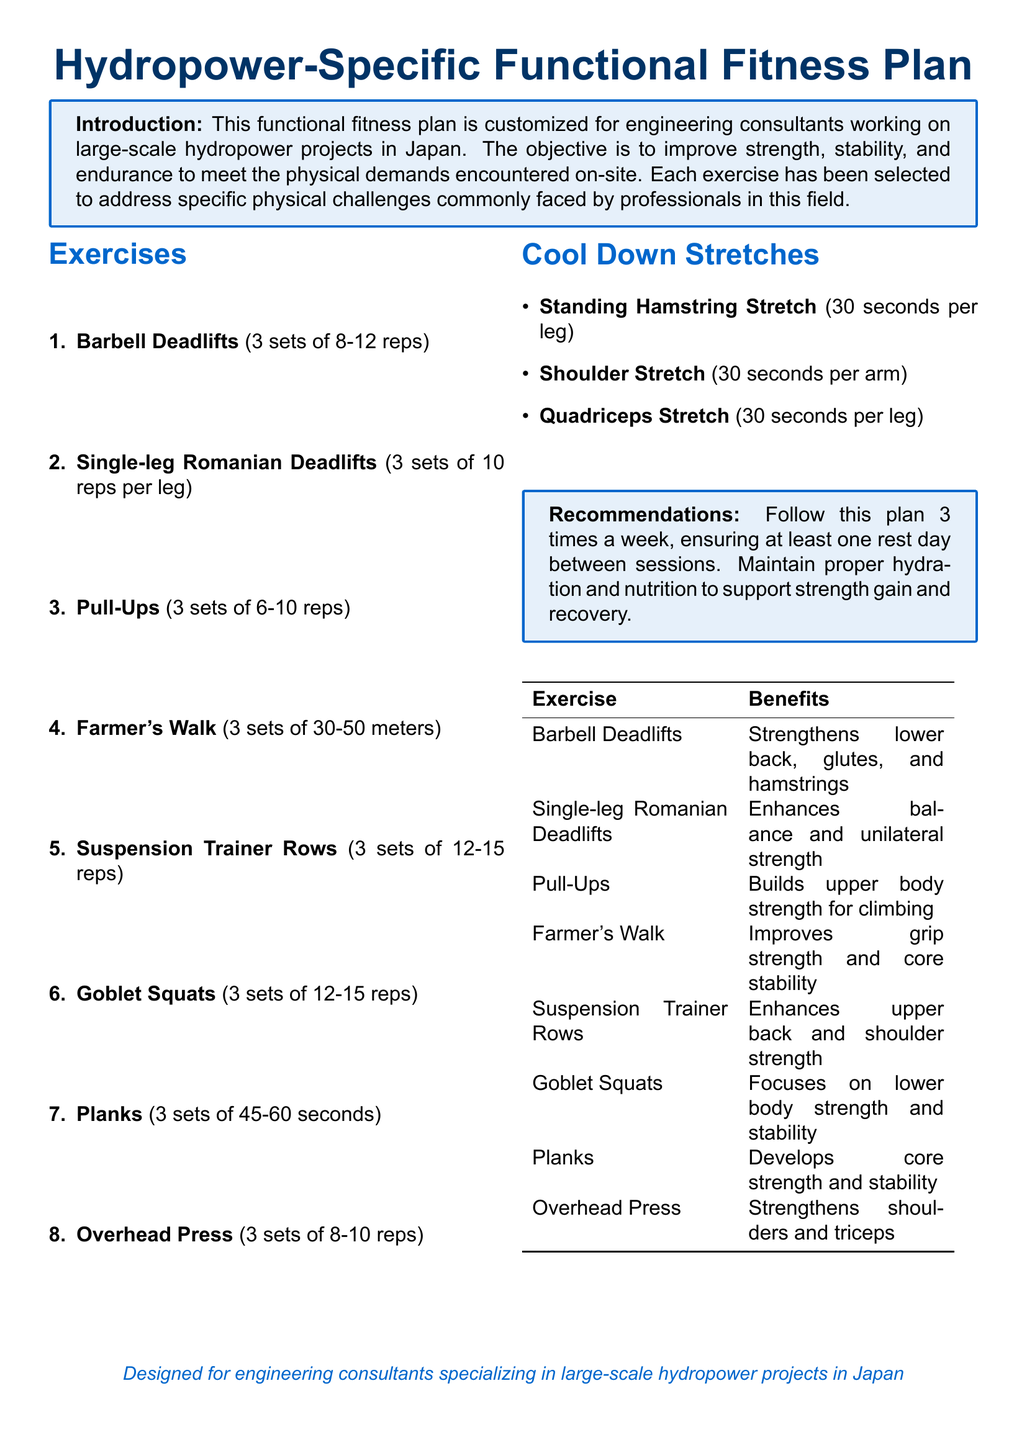What is the title of the document? The title is presented in a large font at the top of the document.
Answer: Hydropower-Specific Functional Fitness Plan How many exercises are listed in the document? The number of exercises is indicated in the enumeration in the exercise section.
Answer: 8 What is the first exercise mentioned? The first exercise is the initial entry in the list of exercises.
Answer: Barbell Deadlifts How many sets are recommended for Goblet Squats? The number of sets is specified next to the exercise name in the list.
Answer: 3 sets What is the duration for holding Planks? The time for maintaining the plank position is stated in the exercise description.
Answer: 45-60 seconds Which exercise is aimed at improving grip strength? The specific benefits of each exercise indicate the focus of grip strength enhancement.
Answer: Farmer's Walk What type of stretch is recommended for the hamstring? The stretches are categorized under cool down stretches with their specific names listed.
Answer: Standing Hamstring Stretch How often should this fitness plan be followed per week? The recommendation section specifies the frequency of the workouts.
Answer: 3 times a week 